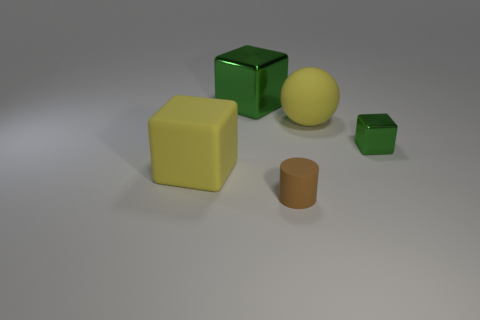Add 2 large purple spheres. How many objects exist? 7 Subtract all cylinders. How many objects are left? 4 Add 3 large yellow blocks. How many large yellow blocks exist? 4 Subtract 0 blue cylinders. How many objects are left? 5 Subtract all yellow objects. Subtract all large yellow matte things. How many objects are left? 1 Add 1 tiny blocks. How many tiny blocks are left? 2 